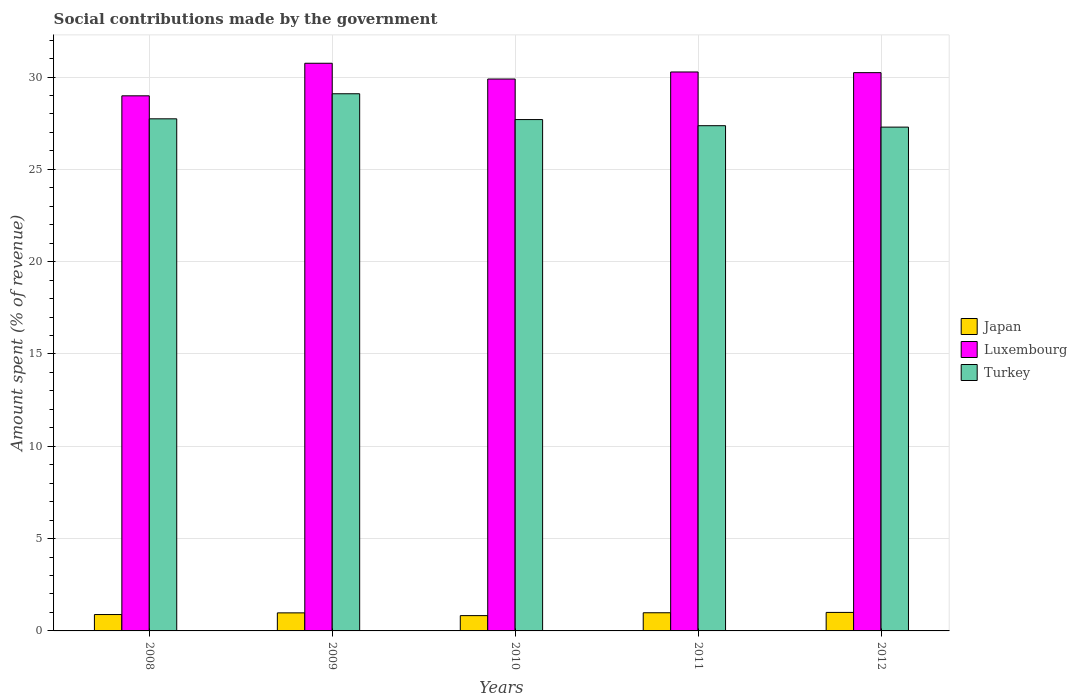Are the number of bars per tick equal to the number of legend labels?
Give a very brief answer. Yes. Are the number of bars on each tick of the X-axis equal?
Ensure brevity in your answer.  Yes. What is the label of the 1st group of bars from the left?
Your response must be concise. 2008. In how many cases, is the number of bars for a given year not equal to the number of legend labels?
Your answer should be compact. 0. What is the amount spent (in %) on social contributions in Turkey in 2009?
Your answer should be very brief. 29.09. Across all years, what is the maximum amount spent (in %) on social contributions in Turkey?
Your answer should be very brief. 29.09. Across all years, what is the minimum amount spent (in %) on social contributions in Luxembourg?
Ensure brevity in your answer.  28.98. In which year was the amount spent (in %) on social contributions in Luxembourg maximum?
Provide a succinct answer. 2009. What is the total amount spent (in %) on social contributions in Japan in the graph?
Your response must be concise. 4.68. What is the difference between the amount spent (in %) on social contributions in Luxembourg in 2009 and that in 2010?
Your answer should be very brief. 0.85. What is the difference between the amount spent (in %) on social contributions in Turkey in 2010 and the amount spent (in %) on social contributions in Japan in 2009?
Provide a succinct answer. 26.72. What is the average amount spent (in %) on social contributions in Turkey per year?
Keep it short and to the point. 27.84. In the year 2012, what is the difference between the amount spent (in %) on social contributions in Luxembourg and amount spent (in %) on social contributions in Japan?
Your answer should be compact. 29.23. What is the ratio of the amount spent (in %) on social contributions in Japan in 2008 to that in 2010?
Your response must be concise. 1.07. Is the difference between the amount spent (in %) on social contributions in Luxembourg in 2008 and 2012 greater than the difference between the amount spent (in %) on social contributions in Japan in 2008 and 2012?
Give a very brief answer. No. What is the difference between the highest and the second highest amount spent (in %) on social contributions in Japan?
Your answer should be very brief. 0.02. What is the difference between the highest and the lowest amount spent (in %) on social contributions in Turkey?
Provide a short and direct response. 1.81. What does the 2nd bar from the left in 2008 represents?
Offer a very short reply. Luxembourg. What does the 1st bar from the right in 2008 represents?
Provide a succinct answer. Turkey. Is it the case that in every year, the sum of the amount spent (in %) on social contributions in Turkey and amount spent (in %) on social contributions in Luxembourg is greater than the amount spent (in %) on social contributions in Japan?
Your answer should be very brief. Yes. How many bars are there?
Ensure brevity in your answer.  15. What is the difference between two consecutive major ticks on the Y-axis?
Provide a short and direct response. 5. Are the values on the major ticks of Y-axis written in scientific E-notation?
Make the answer very short. No. Does the graph contain grids?
Your response must be concise. Yes. Where does the legend appear in the graph?
Your answer should be compact. Center right. How are the legend labels stacked?
Your response must be concise. Vertical. What is the title of the graph?
Provide a succinct answer. Social contributions made by the government. What is the label or title of the Y-axis?
Provide a short and direct response. Amount spent (% of revenue). What is the Amount spent (% of revenue) of Japan in 2008?
Offer a terse response. 0.89. What is the Amount spent (% of revenue) of Luxembourg in 2008?
Provide a short and direct response. 28.98. What is the Amount spent (% of revenue) of Turkey in 2008?
Ensure brevity in your answer.  27.74. What is the Amount spent (% of revenue) of Japan in 2009?
Ensure brevity in your answer.  0.98. What is the Amount spent (% of revenue) in Luxembourg in 2009?
Your answer should be compact. 30.75. What is the Amount spent (% of revenue) in Turkey in 2009?
Ensure brevity in your answer.  29.09. What is the Amount spent (% of revenue) of Japan in 2010?
Your answer should be compact. 0.83. What is the Amount spent (% of revenue) of Luxembourg in 2010?
Give a very brief answer. 29.89. What is the Amount spent (% of revenue) in Turkey in 2010?
Make the answer very short. 27.7. What is the Amount spent (% of revenue) in Japan in 2011?
Keep it short and to the point. 0.98. What is the Amount spent (% of revenue) of Luxembourg in 2011?
Your answer should be very brief. 30.27. What is the Amount spent (% of revenue) in Turkey in 2011?
Make the answer very short. 27.36. What is the Amount spent (% of revenue) in Japan in 2012?
Ensure brevity in your answer.  1. What is the Amount spent (% of revenue) of Luxembourg in 2012?
Provide a short and direct response. 30.24. What is the Amount spent (% of revenue) of Turkey in 2012?
Make the answer very short. 27.29. Across all years, what is the maximum Amount spent (% of revenue) of Japan?
Make the answer very short. 1. Across all years, what is the maximum Amount spent (% of revenue) of Luxembourg?
Provide a succinct answer. 30.75. Across all years, what is the maximum Amount spent (% of revenue) of Turkey?
Provide a succinct answer. 29.09. Across all years, what is the minimum Amount spent (% of revenue) of Japan?
Your answer should be very brief. 0.83. Across all years, what is the minimum Amount spent (% of revenue) in Luxembourg?
Make the answer very short. 28.98. Across all years, what is the minimum Amount spent (% of revenue) in Turkey?
Your answer should be very brief. 27.29. What is the total Amount spent (% of revenue) in Japan in the graph?
Your response must be concise. 4.68. What is the total Amount spent (% of revenue) of Luxembourg in the graph?
Offer a very short reply. 150.13. What is the total Amount spent (% of revenue) of Turkey in the graph?
Offer a terse response. 139.18. What is the difference between the Amount spent (% of revenue) of Japan in 2008 and that in 2009?
Your answer should be compact. -0.09. What is the difference between the Amount spent (% of revenue) of Luxembourg in 2008 and that in 2009?
Provide a short and direct response. -1.76. What is the difference between the Amount spent (% of revenue) of Turkey in 2008 and that in 2009?
Keep it short and to the point. -1.36. What is the difference between the Amount spent (% of revenue) of Japan in 2008 and that in 2010?
Give a very brief answer. 0.06. What is the difference between the Amount spent (% of revenue) in Luxembourg in 2008 and that in 2010?
Make the answer very short. -0.91. What is the difference between the Amount spent (% of revenue) in Turkey in 2008 and that in 2010?
Keep it short and to the point. 0.04. What is the difference between the Amount spent (% of revenue) of Japan in 2008 and that in 2011?
Provide a succinct answer. -0.1. What is the difference between the Amount spent (% of revenue) in Luxembourg in 2008 and that in 2011?
Your answer should be compact. -1.29. What is the difference between the Amount spent (% of revenue) of Turkey in 2008 and that in 2011?
Give a very brief answer. 0.37. What is the difference between the Amount spent (% of revenue) in Japan in 2008 and that in 2012?
Your response must be concise. -0.12. What is the difference between the Amount spent (% of revenue) in Luxembourg in 2008 and that in 2012?
Your answer should be very brief. -1.25. What is the difference between the Amount spent (% of revenue) in Turkey in 2008 and that in 2012?
Make the answer very short. 0.45. What is the difference between the Amount spent (% of revenue) of Japan in 2009 and that in 2010?
Your response must be concise. 0.15. What is the difference between the Amount spent (% of revenue) of Luxembourg in 2009 and that in 2010?
Your answer should be very brief. 0.85. What is the difference between the Amount spent (% of revenue) in Turkey in 2009 and that in 2010?
Give a very brief answer. 1.4. What is the difference between the Amount spent (% of revenue) in Japan in 2009 and that in 2011?
Keep it short and to the point. -0.01. What is the difference between the Amount spent (% of revenue) in Luxembourg in 2009 and that in 2011?
Keep it short and to the point. 0.47. What is the difference between the Amount spent (% of revenue) in Turkey in 2009 and that in 2011?
Your response must be concise. 1.73. What is the difference between the Amount spent (% of revenue) of Japan in 2009 and that in 2012?
Provide a succinct answer. -0.02. What is the difference between the Amount spent (% of revenue) of Luxembourg in 2009 and that in 2012?
Offer a very short reply. 0.51. What is the difference between the Amount spent (% of revenue) in Turkey in 2009 and that in 2012?
Offer a terse response. 1.81. What is the difference between the Amount spent (% of revenue) in Japan in 2010 and that in 2011?
Provide a short and direct response. -0.16. What is the difference between the Amount spent (% of revenue) of Luxembourg in 2010 and that in 2011?
Provide a succinct answer. -0.38. What is the difference between the Amount spent (% of revenue) in Turkey in 2010 and that in 2011?
Provide a short and direct response. 0.33. What is the difference between the Amount spent (% of revenue) of Japan in 2010 and that in 2012?
Keep it short and to the point. -0.17. What is the difference between the Amount spent (% of revenue) in Luxembourg in 2010 and that in 2012?
Your answer should be very brief. -0.34. What is the difference between the Amount spent (% of revenue) in Turkey in 2010 and that in 2012?
Keep it short and to the point. 0.41. What is the difference between the Amount spent (% of revenue) of Japan in 2011 and that in 2012?
Offer a very short reply. -0.02. What is the difference between the Amount spent (% of revenue) of Luxembourg in 2011 and that in 2012?
Offer a terse response. 0.04. What is the difference between the Amount spent (% of revenue) of Turkey in 2011 and that in 2012?
Offer a very short reply. 0.08. What is the difference between the Amount spent (% of revenue) of Japan in 2008 and the Amount spent (% of revenue) of Luxembourg in 2009?
Provide a short and direct response. -29.86. What is the difference between the Amount spent (% of revenue) in Japan in 2008 and the Amount spent (% of revenue) in Turkey in 2009?
Make the answer very short. -28.21. What is the difference between the Amount spent (% of revenue) of Luxembourg in 2008 and the Amount spent (% of revenue) of Turkey in 2009?
Ensure brevity in your answer.  -0.11. What is the difference between the Amount spent (% of revenue) of Japan in 2008 and the Amount spent (% of revenue) of Luxembourg in 2010?
Offer a terse response. -29. What is the difference between the Amount spent (% of revenue) in Japan in 2008 and the Amount spent (% of revenue) in Turkey in 2010?
Ensure brevity in your answer.  -26.81. What is the difference between the Amount spent (% of revenue) of Luxembourg in 2008 and the Amount spent (% of revenue) of Turkey in 2010?
Your response must be concise. 1.29. What is the difference between the Amount spent (% of revenue) in Japan in 2008 and the Amount spent (% of revenue) in Luxembourg in 2011?
Make the answer very short. -29.39. What is the difference between the Amount spent (% of revenue) in Japan in 2008 and the Amount spent (% of revenue) in Turkey in 2011?
Give a very brief answer. -26.48. What is the difference between the Amount spent (% of revenue) in Luxembourg in 2008 and the Amount spent (% of revenue) in Turkey in 2011?
Give a very brief answer. 1.62. What is the difference between the Amount spent (% of revenue) in Japan in 2008 and the Amount spent (% of revenue) in Luxembourg in 2012?
Provide a succinct answer. -29.35. What is the difference between the Amount spent (% of revenue) of Japan in 2008 and the Amount spent (% of revenue) of Turkey in 2012?
Your answer should be compact. -26.4. What is the difference between the Amount spent (% of revenue) of Luxembourg in 2008 and the Amount spent (% of revenue) of Turkey in 2012?
Provide a succinct answer. 1.69. What is the difference between the Amount spent (% of revenue) in Japan in 2009 and the Amount spent (% of revenue) in Luxembourg in 2010?
Offer a very short reply. -28.91. What is the difference between the Amount spent (% of revenue) of Japan in 2009 and the Amount spent (% of revenue) of Turkey in 2010?
Keep it short and to the point. -26.72. What is the difference between the Amount spent (% of revenue) in Luxembourg in 2009 and the Amount spent (% of revenue) in Turkey in 2010?
Offer a terse response. 3.05. What is the difference between the Amount spent (% of revenue) in Japan in 2009 and the Amount spent (% of revenue) in Luxembourg in 2011?
Your answer should be very brief. -29.3. What is the difference between the Amount spent (% of revenue) in Japan in 2009 and the Amount spent (% of revenue) in Turkey in 2011?
Offer a very short reply. -26.39. What is the difference between the Amount spent (% of revenue) in Luxembourg in 2009 and the Amount spent (% of revenue) in Turkey in 2011?
Your answer should be compact. 3.38. What is the difference between the Amount spent (% of revenue) in Japan in 2009 and the Amount spent (% of revenue) in Luxembourg in 2012?
Ensure brevity in your answer.  -29.26. What is the difference between the Amount spent (% of revenue) of Japan in 2009 and the Amount spent (% of revenue) of Turkey in 2012?
Provide a short and direct response. -26.31. What is the difference between the Amount spent (% of revenue) of Luxembourg in 2009 and the Amount spent (% of revenue) of Turkey in 2012?
Offer a very short reply. 3.46. What is the difference between the Amount spent (% of revenue) in Japan in 2010 and the Amount spent (% of revenue) in Luxembourg in 2011?
Your response must be concise. -29.44. What is the difference between the Amount spent (% of revenue) in Japan in 2010 and the Amount spent (% of revenue) in Turkey in 2011?
Give a very brief answer. -26.54. What is the difference between the Amount spent (% of revenue) of Luxembourg in 2010 and the Amount spent (% of revenue) of Turkey in 2011?
Provide a succinct answer. 2.53. What is the difference between the Amount spent (% of revenue) in Japan in 2010 and the Amount spent (% of revenue) in Luxembourg in 2012?
Keep it short and to the point. -29.41. What is the difference between the Amount spent (% of revenue) of Japan in 2010 and the Amount spent (% of revenue) of Turkey in 2012?
Keep it short and to the point. -26.46. What is the difference between the Amount spent (% of revenue) of Luxembourg in 2010 and the Amount spent (% of revenue) of Turkey in 2012?
Provide a succinct answer. 2.6. What is the difference between the Amount spent (% of revenue) in Japan in 2011 and the Amount spent (% of revenue) in Luxembourg in 2012?
Your response must be concise. -29.25. What is the difference between the Amount spent (% of revenue) of Japan in 2011 and the Amount spent (% of revenue) of Turkey in 2012?
Provide a succinct answer. -26.3. What is the difference between the Amount spent (% of revenue) of Luxembourg in 2011 and the Amount spent (% of revenue) of Turkey in 2012?
Make the answer very short. 2.99. What is the average Amount spent (% of revenue) in Japan per year?
Offer a very short reply. 0.94. What is the average Amount spent (% of revenue) of Luxembourg per year?
Give a very brief answer. 30.03. What is the average Amount spent (% of revenue) of Turkey per year?
Your response must be concise. 27.84. In the year 2008, what is the difference between the Amount spent (% of revenue) in Japan and Amount spent (% of revenue) in Luxembourg?
Offer a terse response. -28.09. In the year 2008, what is the difference between the Amount spent (% of revenue) of Japan and Amount spent (% of revenue) of Turkey?
Offer a terse response. -26.85. In the year 2008, what is the difference between the Amount spent (% of revenue) of Luxembourg and Amount spent (% of revenue) of Turkey?
Your response must be concise. 1.25. In the year 2009, what is the difference between the Amount spent (% of revenue) in Japan and Amount spent (% of revenue) in Luxembourg?
Your response must be concise. -29.77. In the year 2009, what is the difference between the Amount spent (% of revenue) of Japan and Amount spent (% of revenue) of Turkey?
Your answer should be very brief. -28.12. In the year 2009, what is the difference between the Amount spent (% of revenue) in Luxembourg and Amount spent (% of revenue) in Turkey?
Your answer should be very brief. 1.65. In the year 2010, what is the difference between the Amount spent (% of revenue) in Japan and Amount spent (% of revenue) in Luxembourg?
Ensure brevity in your answer.  -29.06. In the year 2010, what is the difference between the Amount spent (% of revenue) in Japan and Amount spent (% of revenue) in Turkey?
Make the answer very short. -26.87. In the year 2010, what is the difference between the Amount spent (% of revenue) of Luxembourg and Amount spent (% of revenue) of Turkey?
Your answer should be compact. 2.2. In the year 2011, what is the difference between the Amount spent (% of revenue) of Japan and Amount spent (% of revenue) of Luxembourg?
Your answer should be very brief. -29.29. In the year 2011, what is the difference between the Amount spent (% of revenue) in Japan and Amount spent (% of revenue) in Turkey?
Offer a very short reply. -26.38. In the year 2011, what is the difference between the Amount spent (% of revenue) of Luxembourg and Amount spent (% of revenue) of Turkey?
Offer a terse response. 2.91. In the year 2012, what is the difference between the Amount spent (% of revenue) in Japan and Amount spent (% of revenue) in Luxembourg?
Give a very brief answer. -29.23. In the year 2012, what is the difference between the Amount spent (% of revenue) in Japan and Amount spent (% of revenue) in Turkey?
Offer a terse response. -26.28. In the year 2012, what is the difference between the Amount spent (% of revenue) in Luxembourg and Amount spent (% of revenue) in Turkey?
Provide a succinct answer. 2.95. What is the ratio of the Amount spent (% of revenue) of Japan in 2008 to that in 2009?
Provide a short and direct response. 0.91. What is the ratio of the Amount spent (% of revenue) in Luxembourg in 2008 to that in 2009?
Provide a succinct answer. 0.94. What is the ratio of the Amount spent (% of revenue) of Turkey in 2008 to that in 2009?
Give a very brief answer. 0.95. What is the ratio of the Amount spent (% of revenue) in Japan in 2008 to that in 2010?
Your response must be concise. 1.07. What is the ratio of the Amount spent (% of revenue) of Luxembourg in 2008 to that in 2010?
Your answer should be compact. 0.97. What is the ratio of the Amount spent (% of revenue) of Japan in 2008 to that in 2011?
Ensure brevity in your answer.  0.9. What is the ratio of the Amount spent (% of revenue) in Luxembourg in 2008 to that in 2011?
Keep it short and to the point. 0.96. What is the ratio of the Amount spent (% of revenue) of Turkey in 2008 to that in 2011?
Keep it short and to the point. 1.01. What is the ratio of the Amount spent (% of revenue) of Japan in 2008 to that in 2012?
Offer a very short reply. 0.89. What is the ratio of the Amount spent (% of revenue) of Luxembourg in 2008 to that in 2012?
Ensure brevity in your answer.  0.96. What is the ratio of the Amount spent (% of revenue) in Turkey in 2008 to that in 2012?
Provide a succinct answer. 1.02. What is the ratio of the Amount spent (% of revenue) in Japan in 2009 to that in 2010?
Provide a short and direct response. 1.18. What is the ratio of the Amount spent (% of revenue) of Luxembourg in 2009 to that in 2010?
Ensure brevity in your answer.  1.03. What is the ratio of the Amount spent (% of revenue) in Turkey in 2009 to that in 2010?
Give a very brief answer. 1.05. What is the ratio of the Amount spent (% of revenue) of Japan in 2009 to that in 2011?
Keep it short and to the point. 0.99. What is the ratio of the Amount spent (% of revenue) of Luxembourg in 2009 to that in 2011?
Give a very brief answer. 1.02. What is the ratio of the Amount spent (% of revenue) in Turkey in 2009 to that in 2011?
Ensure brevity in your answer.  1.06. What is the ratio of the Amount spent (% of revenue) of Japan in 2009 to that in 2012?
Ensure brevity in your answer.  0.98. What is the ratio of the Amount spent (% of revenue) in Luxembourg in 2009 to that in 2012?
Give a very brief answer. 1.02. What is the ratio of the Amount spent (% of revenue) of Turkey in 2009 to that in 2012?
Give a very brief answer. 1.07. What is the ratio of the Amount spent (% of revenue) in Japan in 2010 to that in 2011?
Keep it short and to the point. 0.84. What is the ratio of the Amount spent (% of revenue) of Luxembourg in 2010 to that in 2011?
Keep it short and to the point. 0.99. What is the ratio of the Amount spent (% of revenue) in Turkey in 2010 to that in 2011?
Provide a succinct answer. 1.01. What is the ratio of the Amount spent (% of revenue) of Japan in 2010 to that in 2012?
Make the answer very short. 0.83. What is the ratio of the Amount spent (% of revenue) of Japan in 2011 to that in 2012?
Ensure brevity in your answer.  0.98. What is the difference between the highest and the second highest Amount spent (% of revenue) in Japan?
Offer a terse response. 0.02. What is the difference between the highest and the second highest Amount spent (% of revenue) of Luxembourg?
Provide a short and direct response. 0.47. What is the difference between the highest and the second highest Amount spent (% of revenue) of Turkey?
Provide a succinct answer. 1.36. What is the difference between the highest and the lowest Amount spent (% of revenue) of Japan?
Your answer should be compact. 0.17. What is the difference between the highest and the lowest Amount spent (% of revenue) in Luxembourg?
Make the answer very short. 1.76. What is the difference between the highest and the lowest Amount spent (% of revenue) of Turkey?
Give a very brief answer. 1.81. 